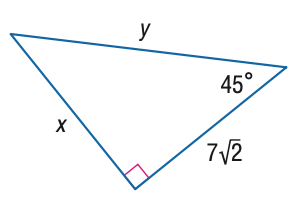Answer the mathemtical geometry problem and directly provide the correct option letter.
Question: Find x.
Choices: A: 7 B: 7 \sqrt { 2 } C: 14 D: 7 \sqrt { 6 } B 